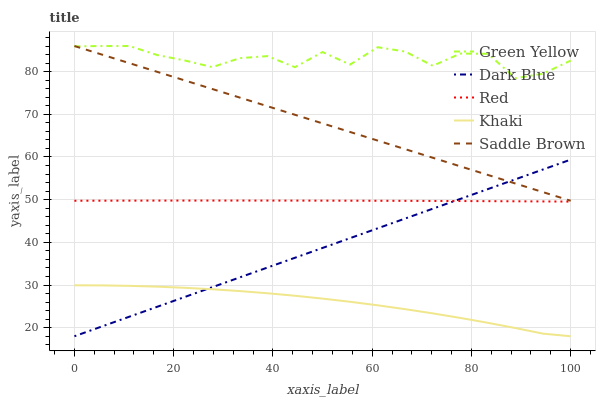Does Khaki have the minimum area under the curve?
Answer yes or no. Yes. Does Green Yellow have the maximum area under the curve?
Answer yes or no. Yes. Does Green Yellow have the minimum area under the curve?
Answer yes or no. No. Does Khaki have the maximum area under the curve?
Answer yes or no. No. Is Saddle Brown the smoothest?
Answer yes or no. Yes. Is Green Yellow the roughest?
Answer yes or no. Yes. Is Khaki the smoothest?
Answer yes or no. No. Is Khaki the roughest?
Answer yes or no. No. Does Dark Blue have the lowest value?
Answer yes or no. Yes. Does Green Yellow have the lowest value?
Answer yes or no. No. Does Saddle Brown have the highest value?
Answer yes or no. Yes. Does Khaki have the highest value?
Answer yes or no. No. Is Dark Blue less than Green Yellow?
Answer yes or no. Yes. Is Red greater than Khaki?
Answer yes or no. Yes. Does Saddle Brown intersect Dark Blue?
Answer yes or no. Yes. Is Saddle Brown less than Dark Blue?
Answer yes or no. No. Is Saddle Brown greater than Dark Blue?
Answer yes or no. No. Does Dark Blue intersect Green Yellow?
Answer yes or no. No. 